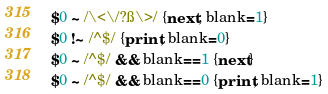<code> <loc_0><loc_0><loc_500><loc_500><_Awk_>$0 ~ /\<\/?ß\>/ {next; blank=1}
$0 !~ /^$/ {print; blank=0}
$0 ~ /^$/ && blank==1 {next}
$0 ~ /^$/ && blank==0 {print; blank=1}
</code> 